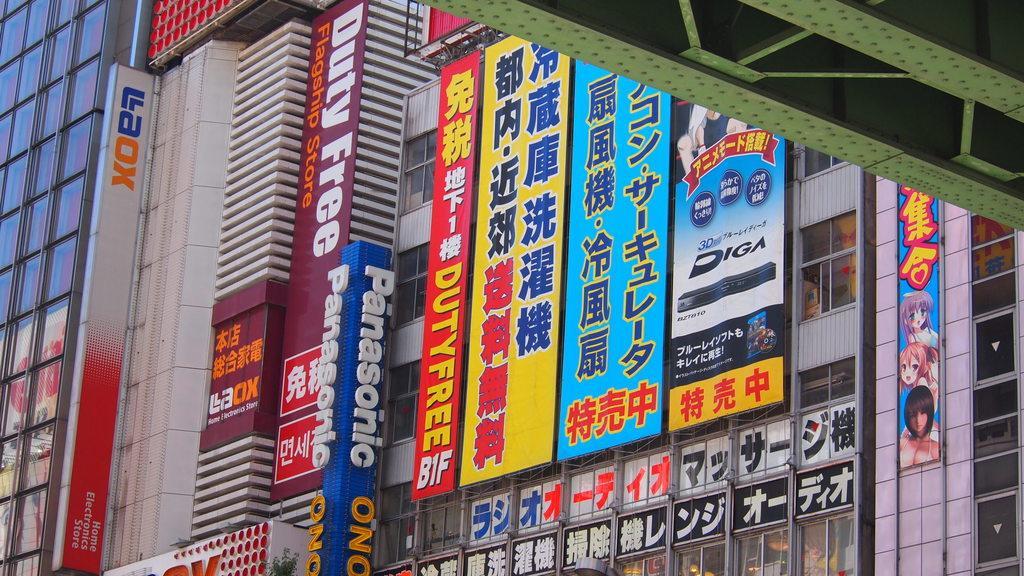Please provide a concise description of this image. In this image there are buildings and we can see boards. 